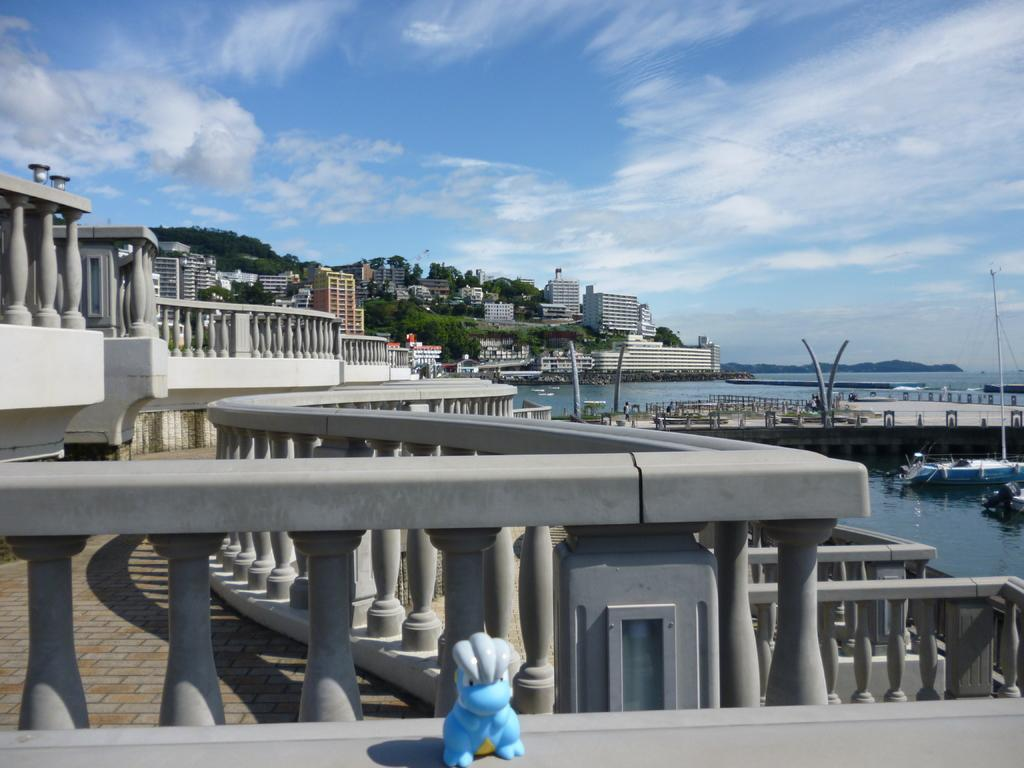What type of structures can be seen in the image? There are buildings in the image. What other natural elements are present in the image? There are trees in the image. What can be seen in the water in the image? There are boats in the water. Is there any architectural feature that connects the two sides of the water? Yes, there appears to be a bridge in the image. What type of object is visible that is not related to the main scene? There is a toy visible in the image. How would you describe the sky in the image? The sky is blue and cloudy. What is the position of the elbow in the image? There is no mention of an elbow in the image, as it features buildings, trees, boats, a bridge, a toy, and a blue and cloudy sky. What does the image need to be considered complete? The image is already complete as it is, as it contains all the necessary elements mentioned in the facts. 